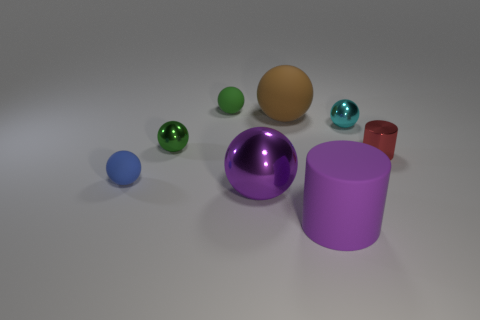Subtract all green spheres. How many spheres are left? 4 Subtract 1 balls. How many balls are left? 5 Subtract all large balls. How many balls are left? 4 Subtract all brown spheres. Subtract all cyan blocks. How many spheres are left? 5 Add 1 big brown things. How many objects exist? 9 Subtract all spheres. How many objects are left? 2 Add 6 large cylinders. How many large cylinders are left? 7 Add 3 green shiny objects. How many green shiny objects exist? 4 Subtract 0 gray cylinders. How many objects are left? 8 Subtract all big purple spheres. Subtract all small cyan metallic things. How many objects are left? 6 